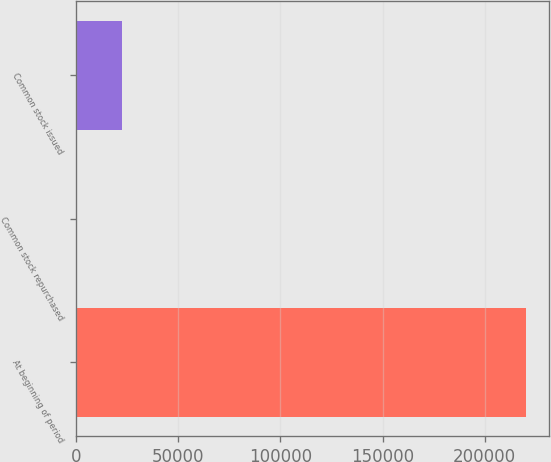Convert chart. <chart><loc_0><loc_0><loc_500><loc_500><bar_chart><fcel>At beginning of period<fcel>Common stock repurchased<fcel>Common stock issued<nl><fcel>220497<fcel>98<fcel>22137.9<nl></chart> 